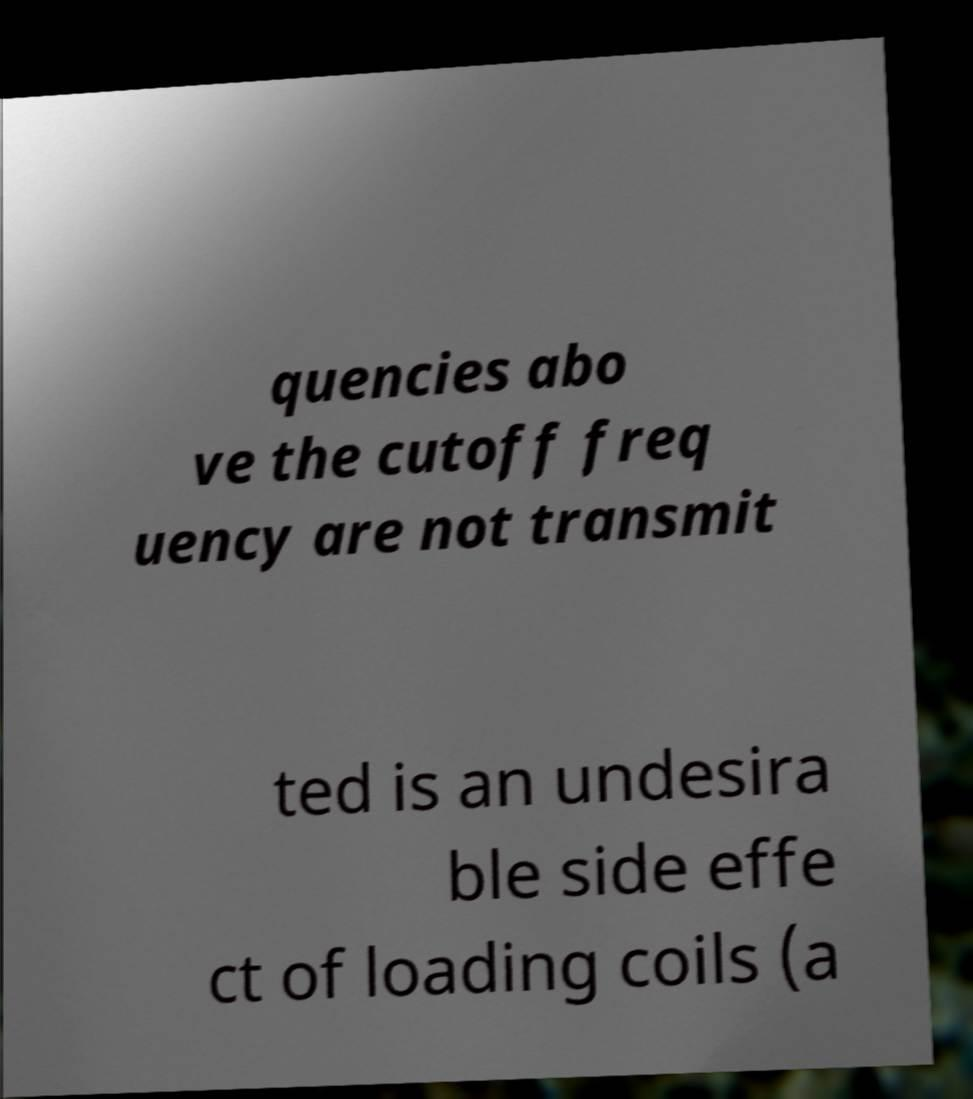What messages or text are displayed in this image? I need them in a readable, typed format. quencies abo ve the cutoff freq uency are not transmit ted is an undesira ble side effe ct of loading coils (a 